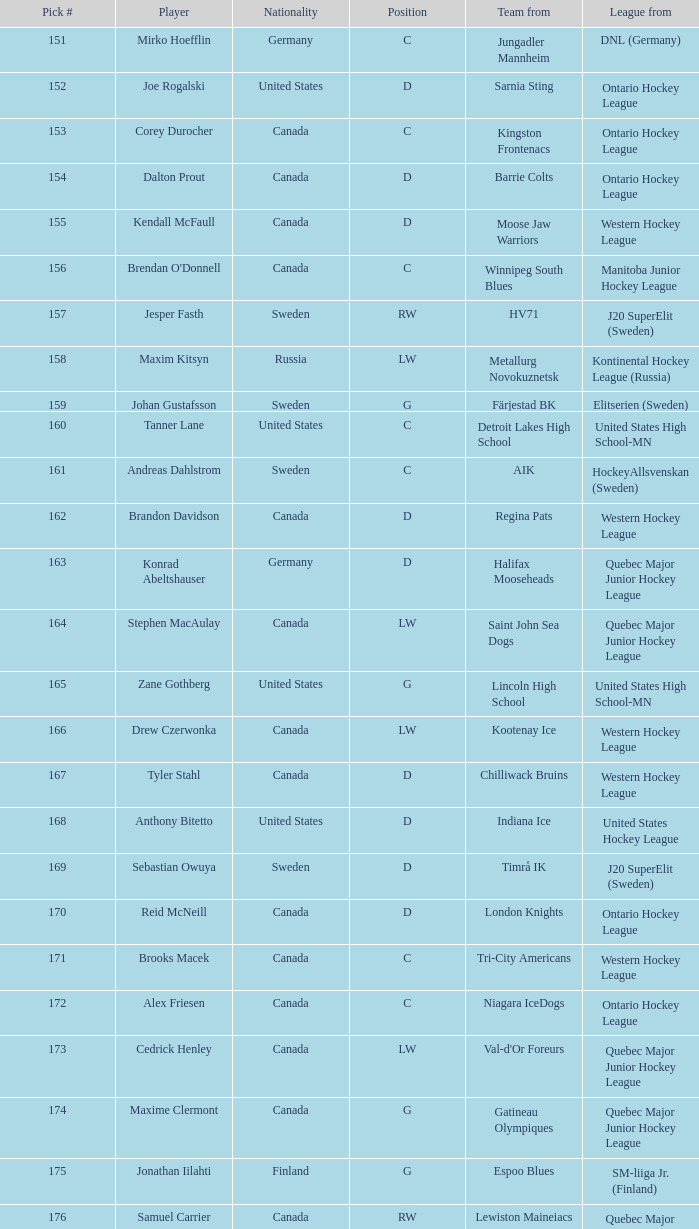What is the total pick # for the D position from a team from Chilliwack Bruins? 167.0. 